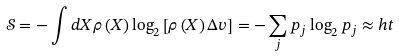Convert formula to latex. <formula><loc_0><loc_0><loc_500><loc_500>\mathcal { S } = - \int d X \rho \left ( X \right ) \log _ { 2 } \left [ \rho \left ( X \right ) \Delta v \right ] = - \sum _ { j } p _ { j } \log _ { 2 } p _ { j } \approx h t</formula> 